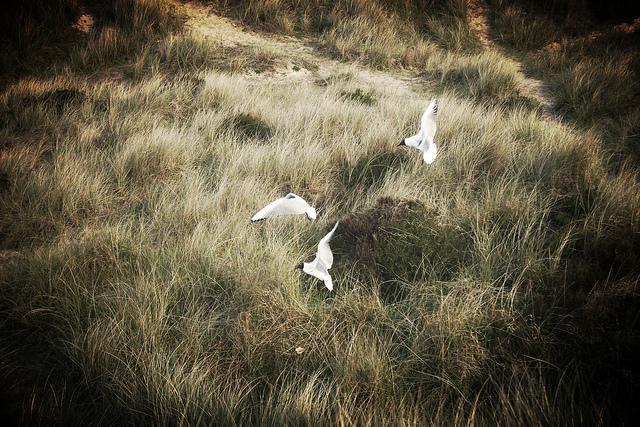How many birds are pictured?
Give a very brief answer. 3. How many birds?
Give a very brief answer. 3. 